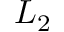<formula> <loc_0><loc_0><loc_500><loc_500>L _ { 2 }</formula> 